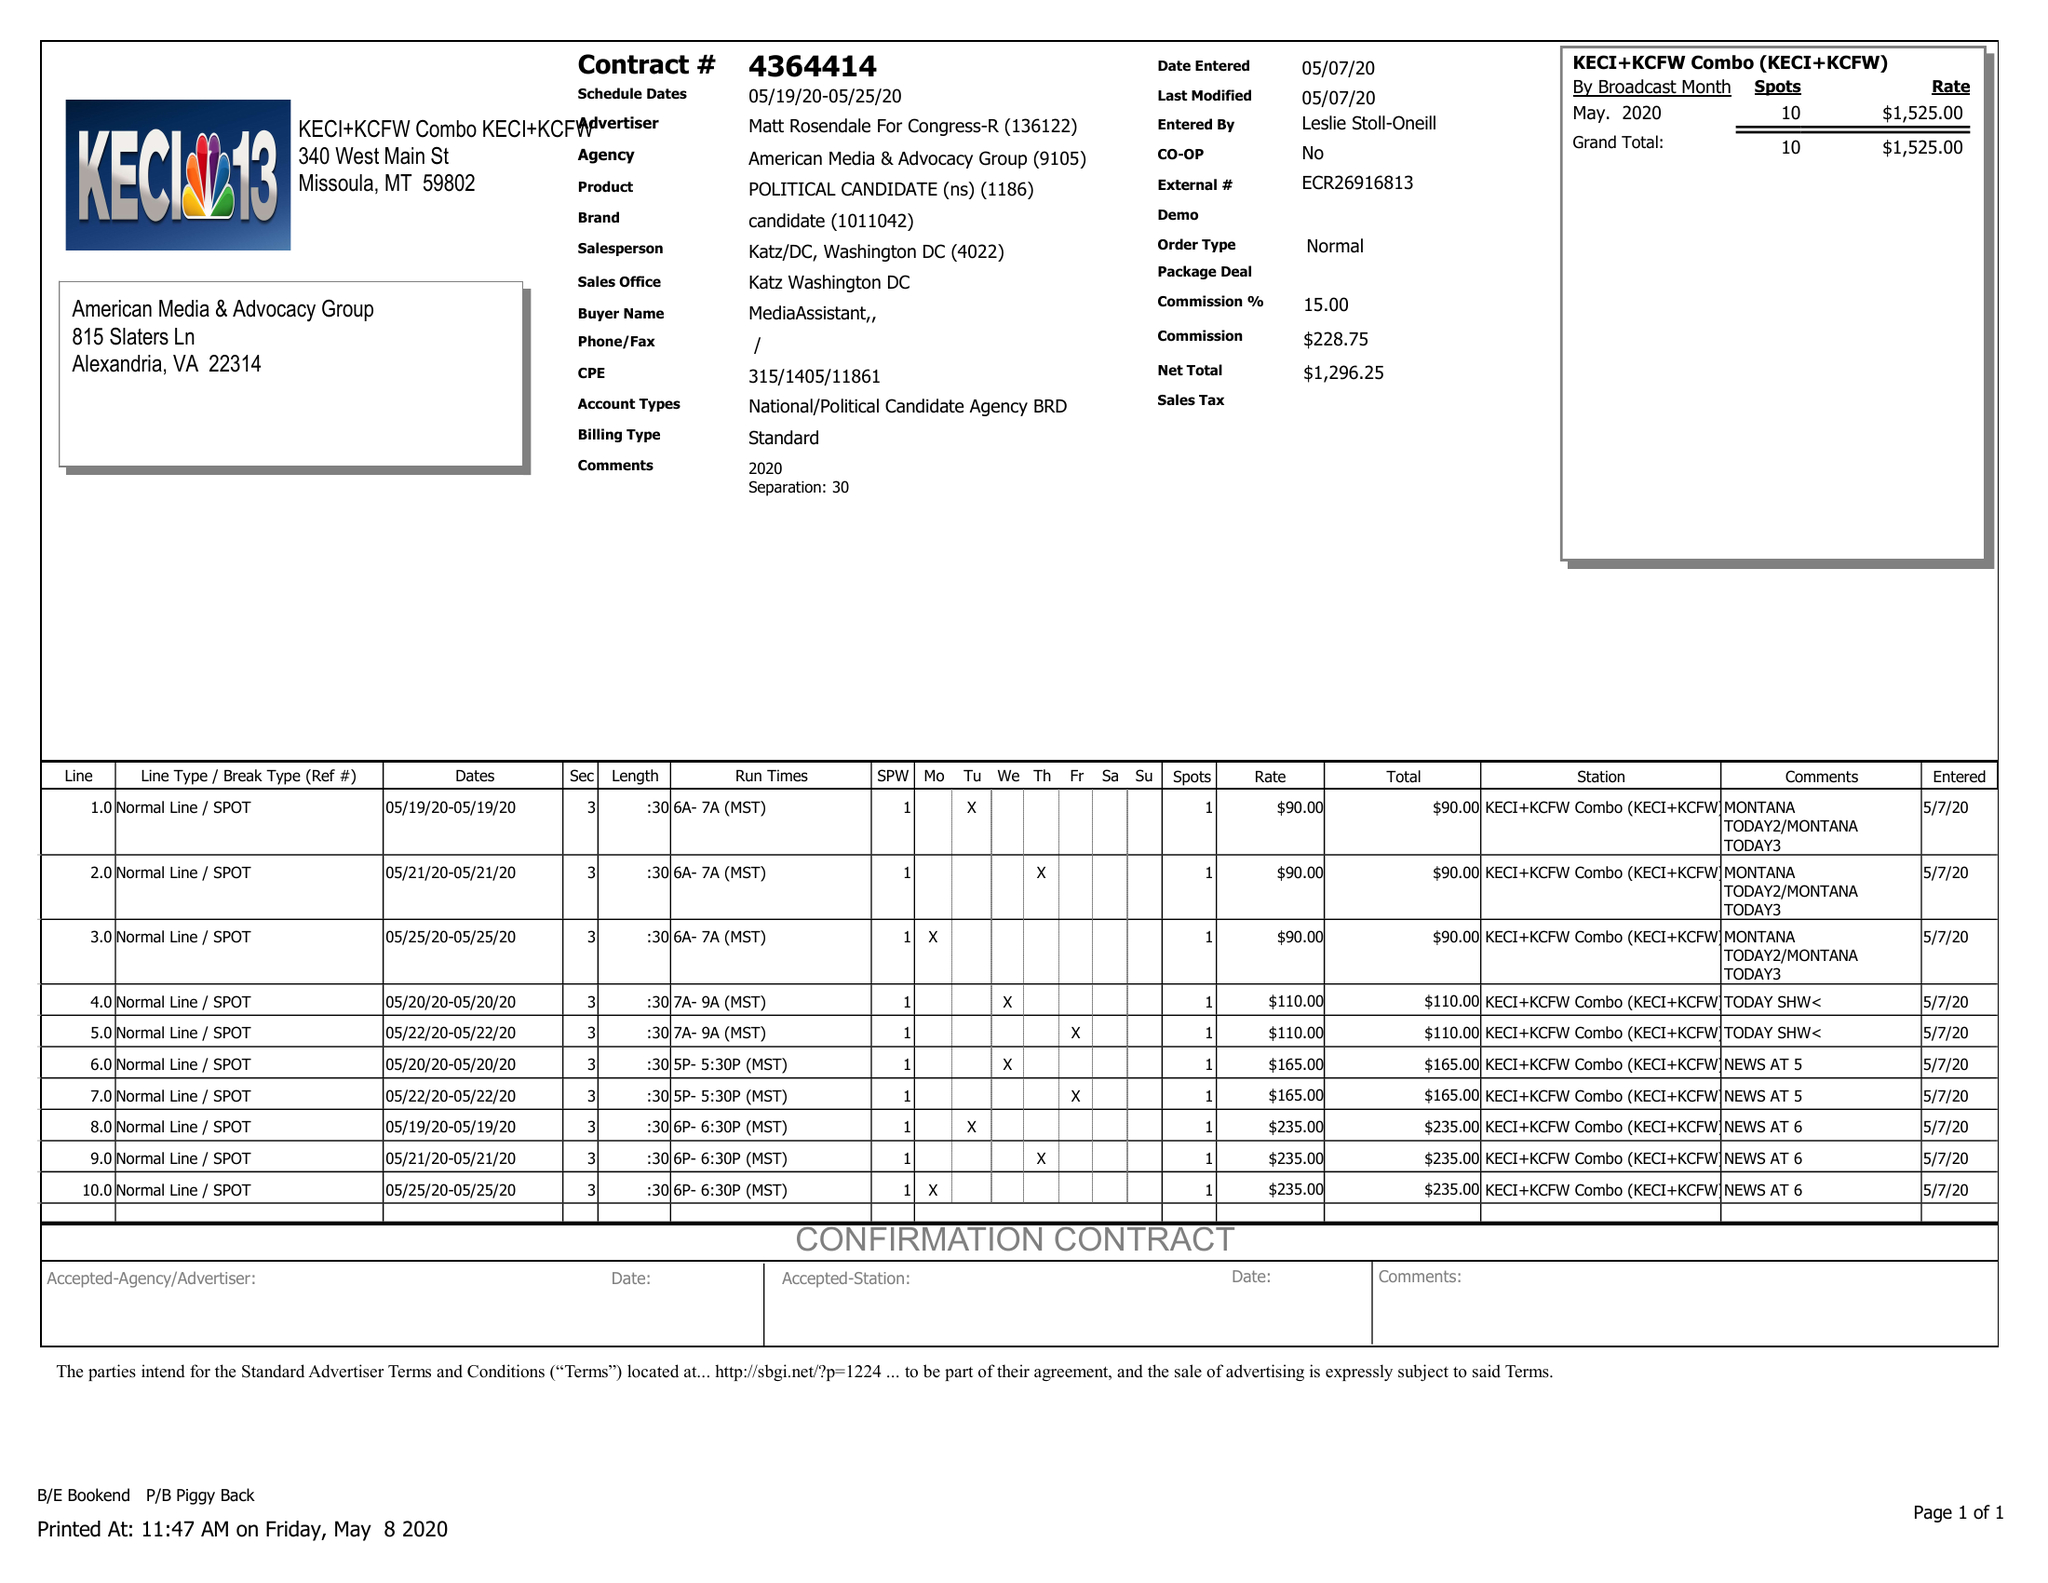What is the value for the advertiser?
Answer the question using a single word or phrase. MATT ROSENDALE FOR CONGRESS-R 